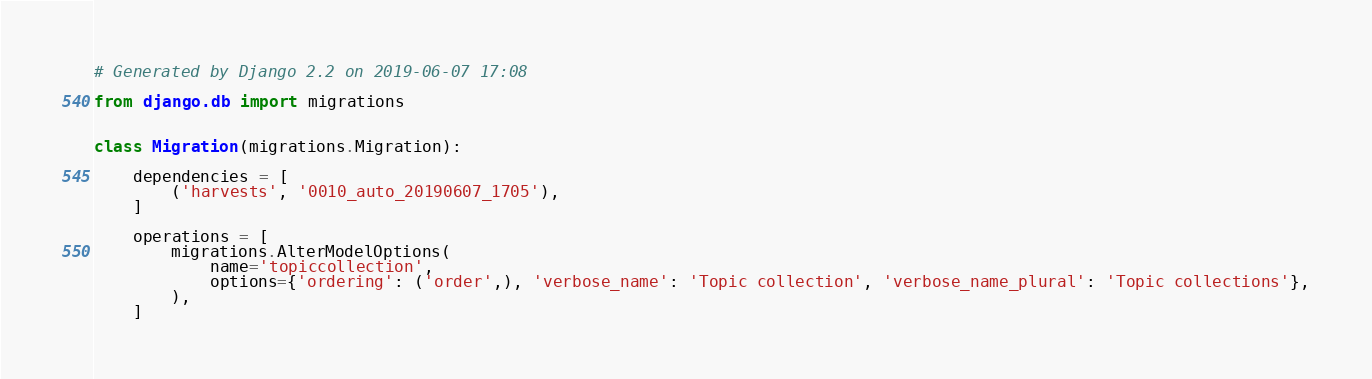Convert code to text. <code><loc_0><loc_0><loc_500><loc_500><_Python_># Generated by Django 2.2 on 2019-06-07 17:08

from django.db import migrations


class Migration(migrations.Migration):

    dependencies = [
        ('harvests', '0010_auto_20190607_1705'),
    ]

    operations = [
        migrations.AlterModelOptions(
            name='topiccollection',
            options={'ordering': ('order',), 'verbose_name': 'Topic collection', 'verbose_name_plural': 'Topic collections'},
        ),
    ]
</code> 